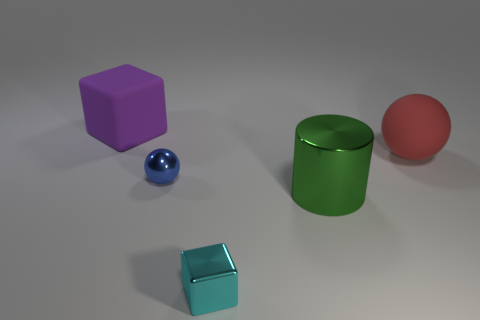What number of other things are there of the same size as the green metal cylinder?
Your answer should be very brief. 2. What number of blocks are tiny red shiny things or purple things?
Offer a terse response. 1. There is a cube that is behind the ball behind the shiny object to the left of the cyan block; what is its material?
Provide a succinct answer. Rubber. What number of big red balls are made of the same material as the cyan thing?
Keep it short and to the point. 0. There is a matte object behind the red sphere; is its size the same as the tiny cyan metal object?
Make the answer very short. No. There is a cube that is made of the same material as the blue object; what is its color?
Your response must be concise. Cyan. How many tiny blue spheres are on the left side of the large cube?
Provide a succinct answer. 0. The large thing that is the same shape as the small cyan thing is what color?
Your answer should be very brief. Purple. Are there any other things that have the same shape as the big shiny thing?
Make the answer very short. No. Do the large rubber thing that is on the left side of the rubber ball and the rubber thing to the right of the blue metal thing have the same shape?
Offer a very short reply. No. 